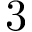Convert formula to latex. <formula><loc_0><loc_0><loc_500><loc_500>3</formula> 